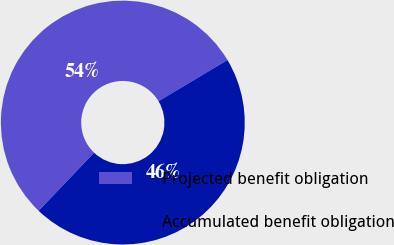Convert chart to OTSL. <chart><loc_0><loc_0><loc_500><loc_500><pie_chart><fcel>Projected benefit obligation<fcel>Accumulated benefit obligation<nl><fcel>54.3%<fcel>45.7%<nl></chart> 